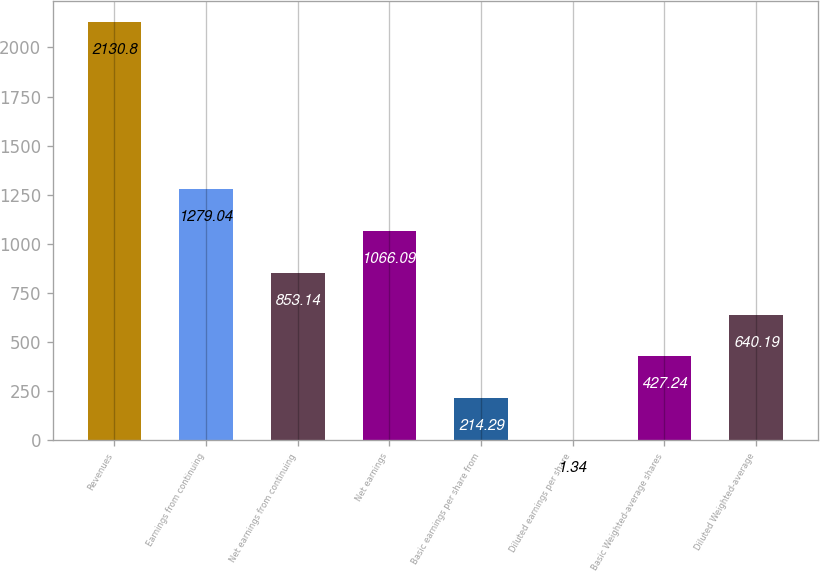Convert chart. <chart><loc_0><loc_0><loc_500><loc_500><bar_chart><fcel>Revenues<fcel>Earnings from continuing<fcel>Net earnings from continuing<fcel>Net earnings<fcel>Basic earnings per share from<fcel>Diluted earnings per share<fcel>Basic Weighted-average shares<fcel>Diluted Weighted-average<nl><fcel>2130.8<fcel>1279.04<fcel>853.14<fcel>1066.09<fcel>214.29<fcel>1.34<fcel>427.24<fcel>640.19<nl></chart> 